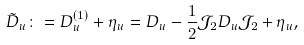<formula> <loc_0><loc_0><loc_500><loc_500>\tilde { D } _ { u } \colon = D ^ { ( 1 ) } _ { u } + \eta _ { u } = D _ { u } - \frac { 1 } { 2 } \mathcal { J } _ { 2 } D _ { u } \mathcal { J } _ { 2 } + \eta _ { u } ,</formula> 